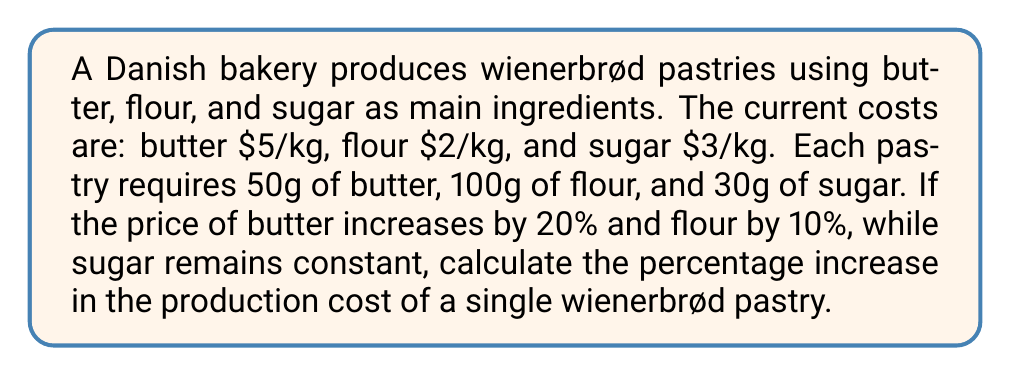Could you help me with this problem? Let's approach this step-by-step:

1. Calculate the initial cost of ingredients per pastry:
   - Butter: $50g * ($5/1000g) = $0.25
   - Flour: $100g * ($2/1000g) = $0.20
   - Sugar: $30g * ($3/1000g) = $0.09
   Total initial cost: $0.25 + $0.20 + $0.09 = $0.54

2. Calculate the new prices after the increases:
   - Butter: $5 * 1.20 = $6/kg
   - Flour: $2 * 1.10 = $2.20/kg
   - Sugar: Remains $3/kg

3. Calculate the new cost of ingredients per pastry:
   - Butter: $50g * ($6/1000g) = $0.30
   - Flour: $100g * ($2.20/1000g) = $0.22
   - Sugar: $30g * ($3/1000g) = $0.09 (unchanged)
   Total new cost: $0.30 + $0.22 + $0.09 = $0.61

4. Calculate the percentage increase:
   $$ \text{Percentage Increase} = \frac{\text{New Cost} - \text{Initial Cost}}{\text{Initial Cost}} * 100\% $$
   $$ = \frac{0.61 - 0.54}{0.54} * 100\% $$
   $$ = \frac{0.07}{0.54} * 100\% $$
   $$ \approx 12.96\% $$
Answer: 12.96% 